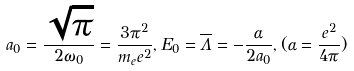Convert formula to latex. <formula><loc_0><loc_0><loc_500><loc_500>a _ { 0 } = { \frac { \sqrt { \pi } } { 2 \omega _ { 0 } } } = { \frac { 3 \pi ^ { 2 } } { m _ { e } e ^ { 2 } } } , E _ { 0 } = \overline { \Lambda } = - { \frac { \alpha } { 2 a _ { 0 } } } , ( \alpha = { \frac { e ^ { 2 } } { 4 \pi } } )</formula> 